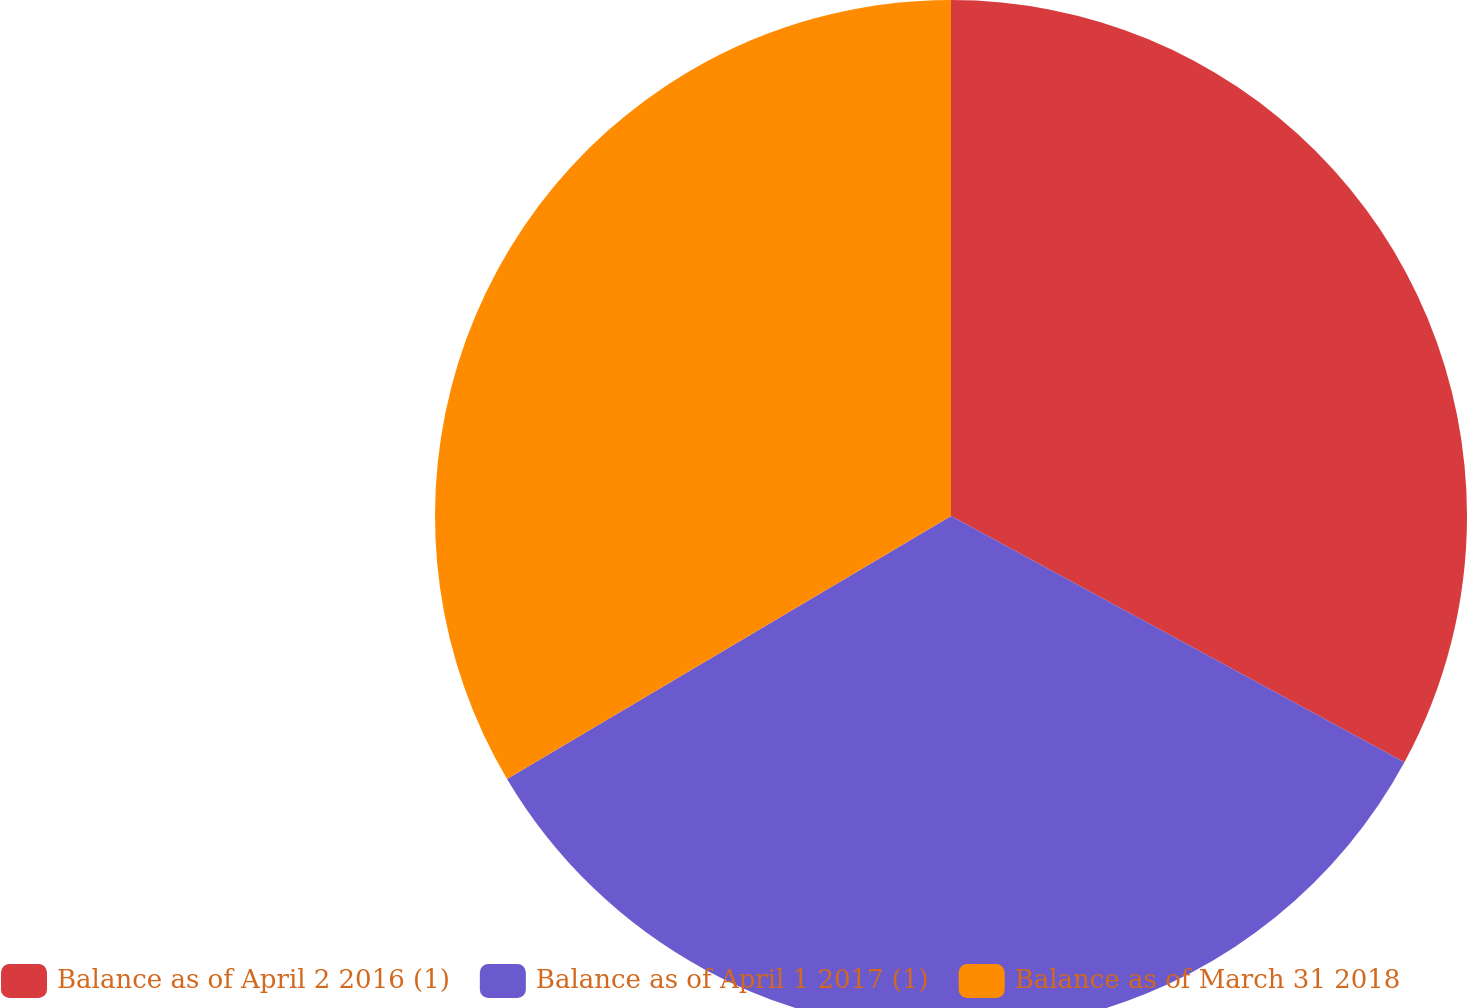Convert chart to OTSL. <chart><loc_0><loc_0><loc_500><loc_500><pie_chart><fcel>Balance as of April 2 2016 (1)<fcel>Balance as of April 1 2017 (1)<fcel>Balance as of March 31 2018<nl><fcel>32.92%<fcel>33.57%<fcel>33.51%<nl></chart> 